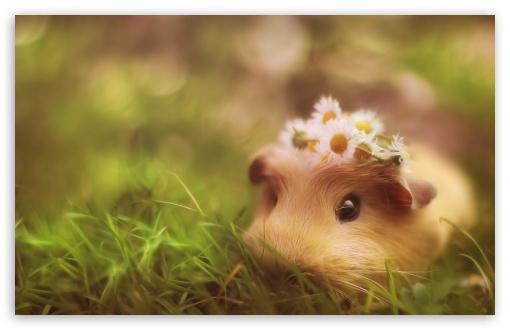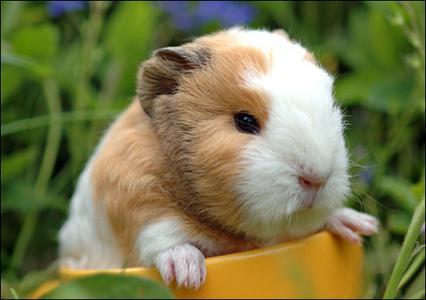The first image is the image on the left, the second image is the image on the right. For the images shown, is this caption "One of the images shows a guinea pig with daisies on its head." true? Answer yes or no. Yes. 